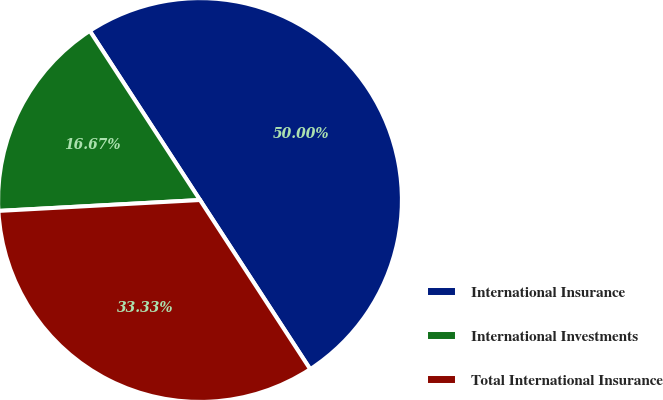<chart> <loc_0><loc_0><loc_500><loc_500><pie_chart><fcel>International Insurance<fcel>International Investments<fcel>Total International Insurance<nl><fcel>50.0%<fcel>16.67%<fcel>33.33%<nl></chart> 